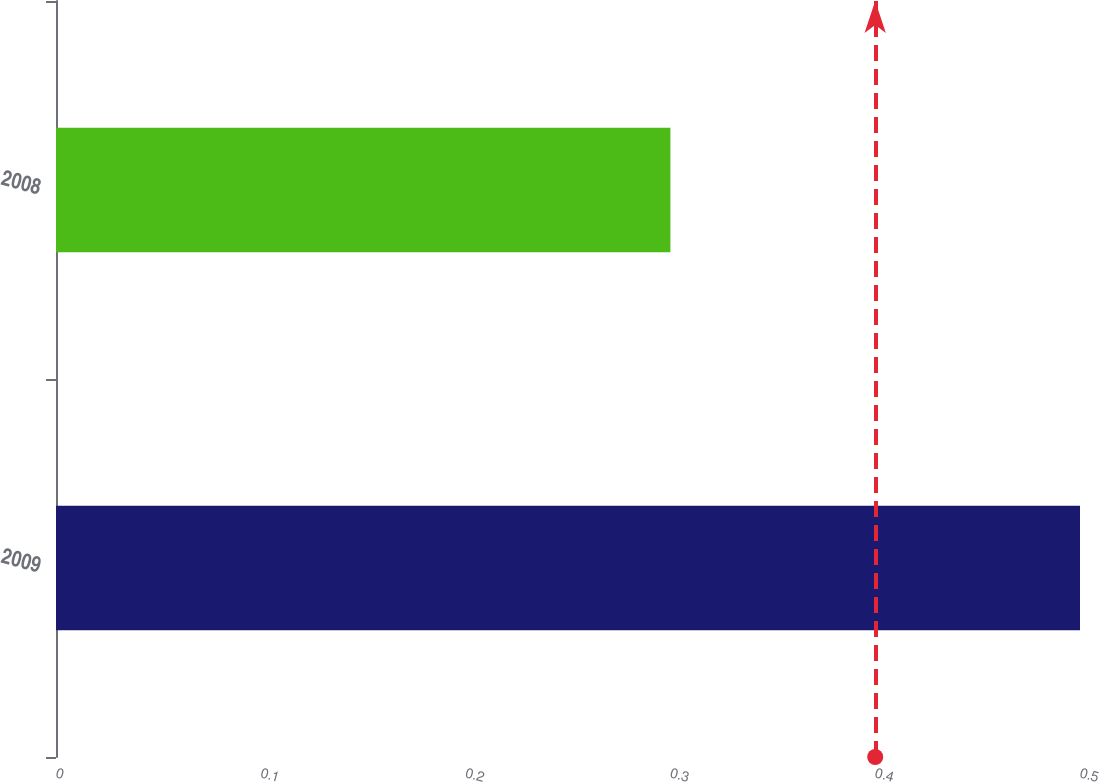Convert chart to OTSL. <chart><loc_0><loc_0><loc_500><loc_500><bar_chart><fcel>2009<fcel>2008<nl><fcel>0.5<fcel>0.3<nl></chart> 